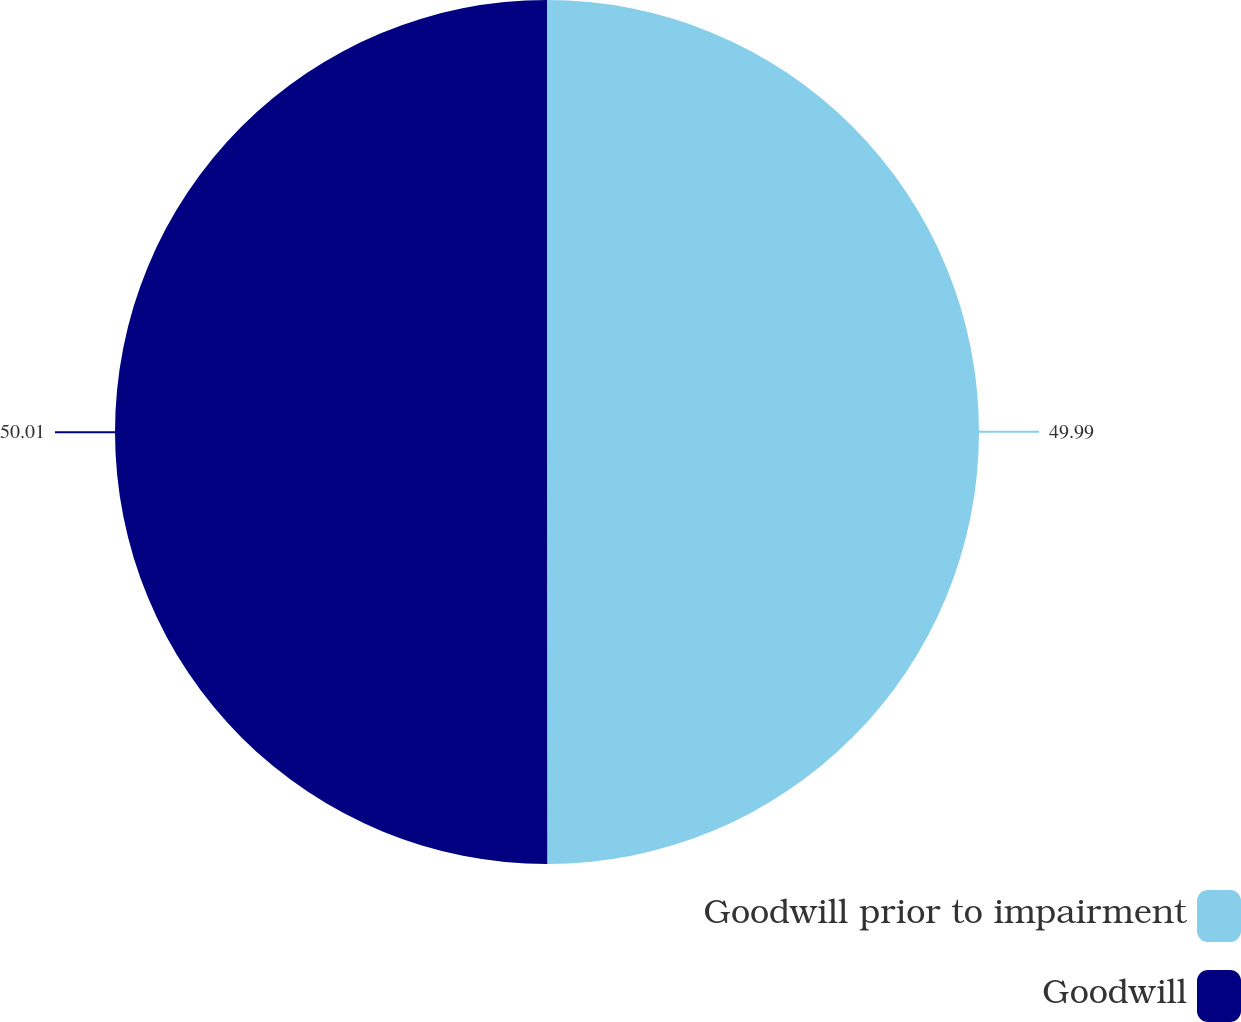Convert chart. <chart><loc_0><loc_0><loc_500><loc_500><pie_chart><fcel>Goodwill prior to impairment<fcel>Goodwill<nl><fcel>49.99%<fcel>50.01%<nl></chart> 